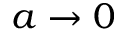<formula> <loc_0><loc_0><loc_500><loc_500>a \to 0</formula> 